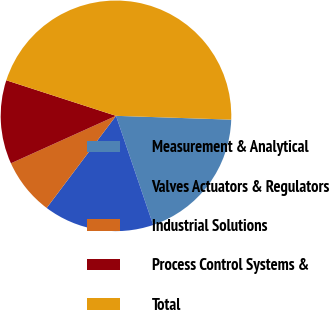Convert chart. <chart><loc_0><loc_0><loc_500><loc_500><pie_chart><fcel>Measurement & Analytical<fcel>Valves Actuators & Regulators<fcel>Industrial Solutions<fcel>Process Control Systems &<fcel>Total<nl><fcel>19.25%<fcel>15.49%<fcel>7.98%<fcel>11.74%<fcel>45.54%<nl></chart> 